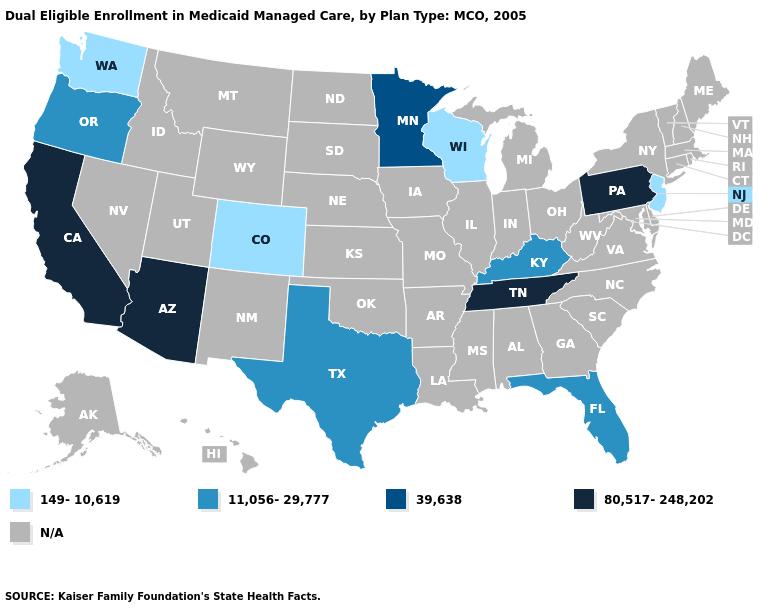Name the states that have a value in the range 80,517-248,202?
Short answer required. Arizona, California, Pennsylvania, Tennessee. Is the legend a continuous bar?
Write a very short answer. No. Name the states that have a value in the range 39,638?
Write a very short answer. Minnesota. Among the states that border Nevada , which have the lowest value?
Short answer required. Oregon. What is the value of Wisconsin?
Write a very short answer. 149-10,619. What is the value of Oklahoma?
Keep it brief. N/A. Name the states that have a value in the range 80,517-248,202?
Quick response, please. Arizona, California, Pennsylvania, Tennessee. What is the value of Massachusetts?
Short answer required. N/A. Name the states that have a value in the range 11,056-29,777?
Be succinct. Florida, Kentucky, Oregon, Texas. Does Florida have the lowest value in the South?
Give a very brief answer. Yes. What is the value of Texas?
Concise answer only. 11,056-29,777. Which states have the highest value in the USA?
Concise answer only. Arizona, California, Pennsylvania, Tennessee. What is the value of South Dakota?
Give a very brief answer. N/A. 